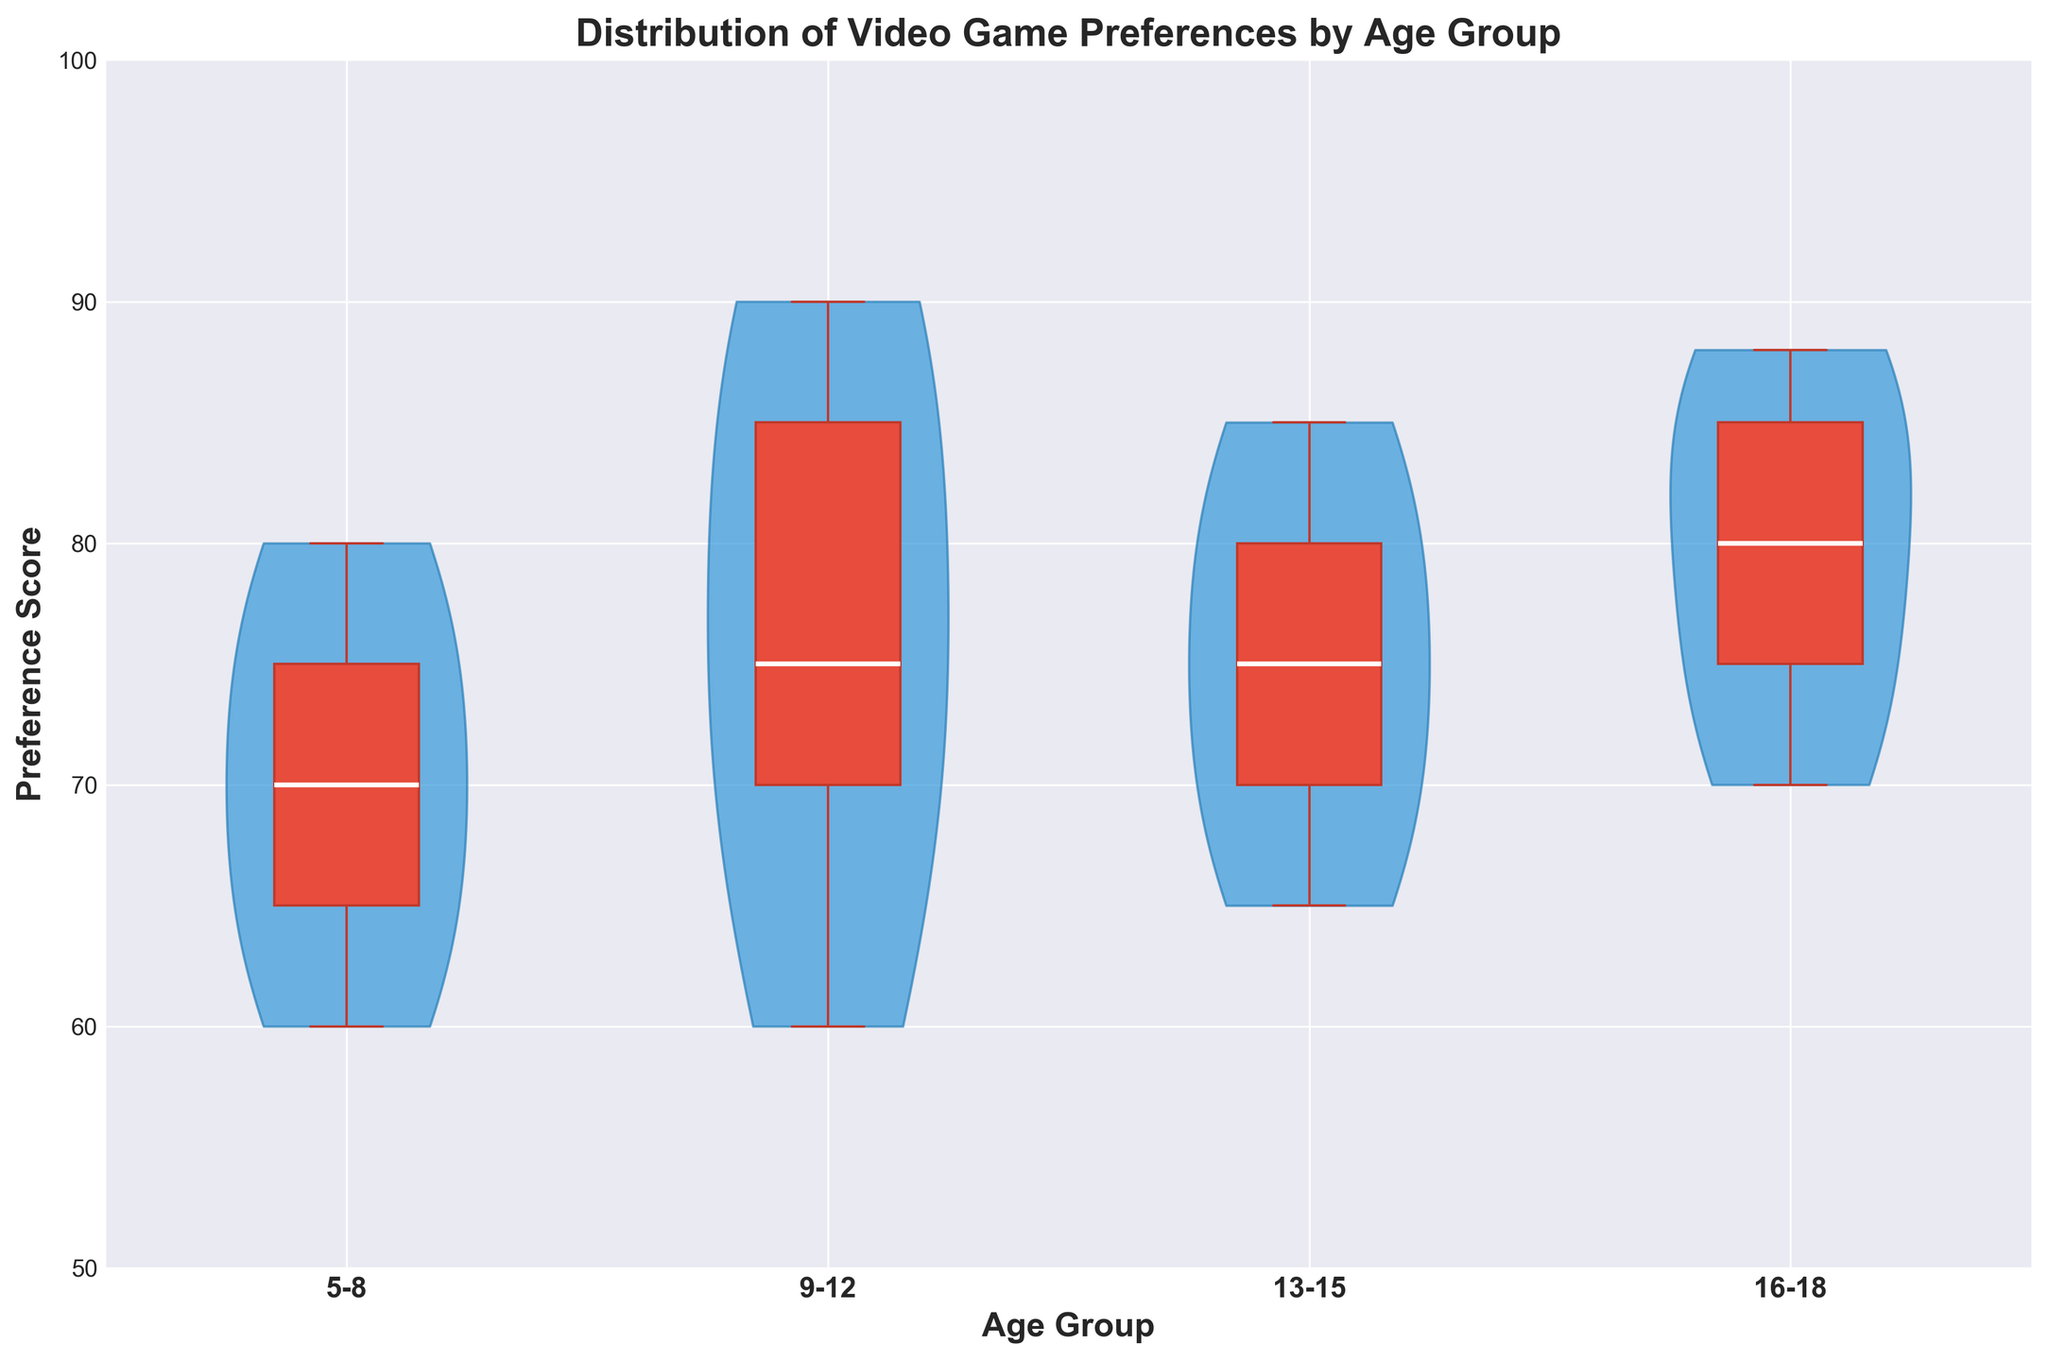What is the preference score range for the 5-8 age group? By reviewing the violin and box plot for the 5-8 age group, we note the spread and the box plot whiskers. The range is from the minimum to the maximum whisker values.
Answer: 60 to 80 Which age group shows the highest median preference score? We examine the horizontal line within the box for each age group to find the median scores. The 16-18 age group has the highest median value.
Answer: 16-18 Is there an age group with a median score above 85? By checking the median line within each box plot, we see that none of the medians are above 85.
Answer: No Which age group's preference scores have the widest distribution? To determine the widest distribution, we look at the spread and the shapes of the violins. The 16-18 age group has the widest distribution.
Answer: 16-18 How do the medians of the 9-12 and 13-15 age groups compare? We compare the median lines within the box plots of both groups. Both the 9-12 and 13-15 groups have medians at 70.
Answer: They are equal Which age group has the narrowest interquartile range (IQR)? The IQR can be found by observing the height of the box for each group. The narrowest IQR is seen in the 5-8 age group.
Answer: 5-8 Does any age group have a score as low as 50? To determine this, we observe the minimum whisker values for all age groups. The lowest score across all groups is 60.
Answer: No Among the age groups, which has the lowest maximum preference score? We identify the highest whisker point for each age group and compare them. The 9-12 age group has the lowest maximum preference score of 90.
Answer: 9-12 How does the average preference score of the 13-15 age group compare to that of the 16-18 age group? We need to estimate the average by looking at the central tendency of each group's distribution. The median of 13-15 is 70 and for 16-18 is 80. Since 16-18 has a slightly higher central value and more closely clustered higher scores, it likely has a higher average.
Answer: 16-18 higher 